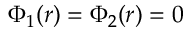Convert formula to latex. <formula><loc_0><loc_0><loc_500><loc_500>\Phi _ { 1 } ( r ) = \Phi _ { 2 } ( r ) = 0</formula> 